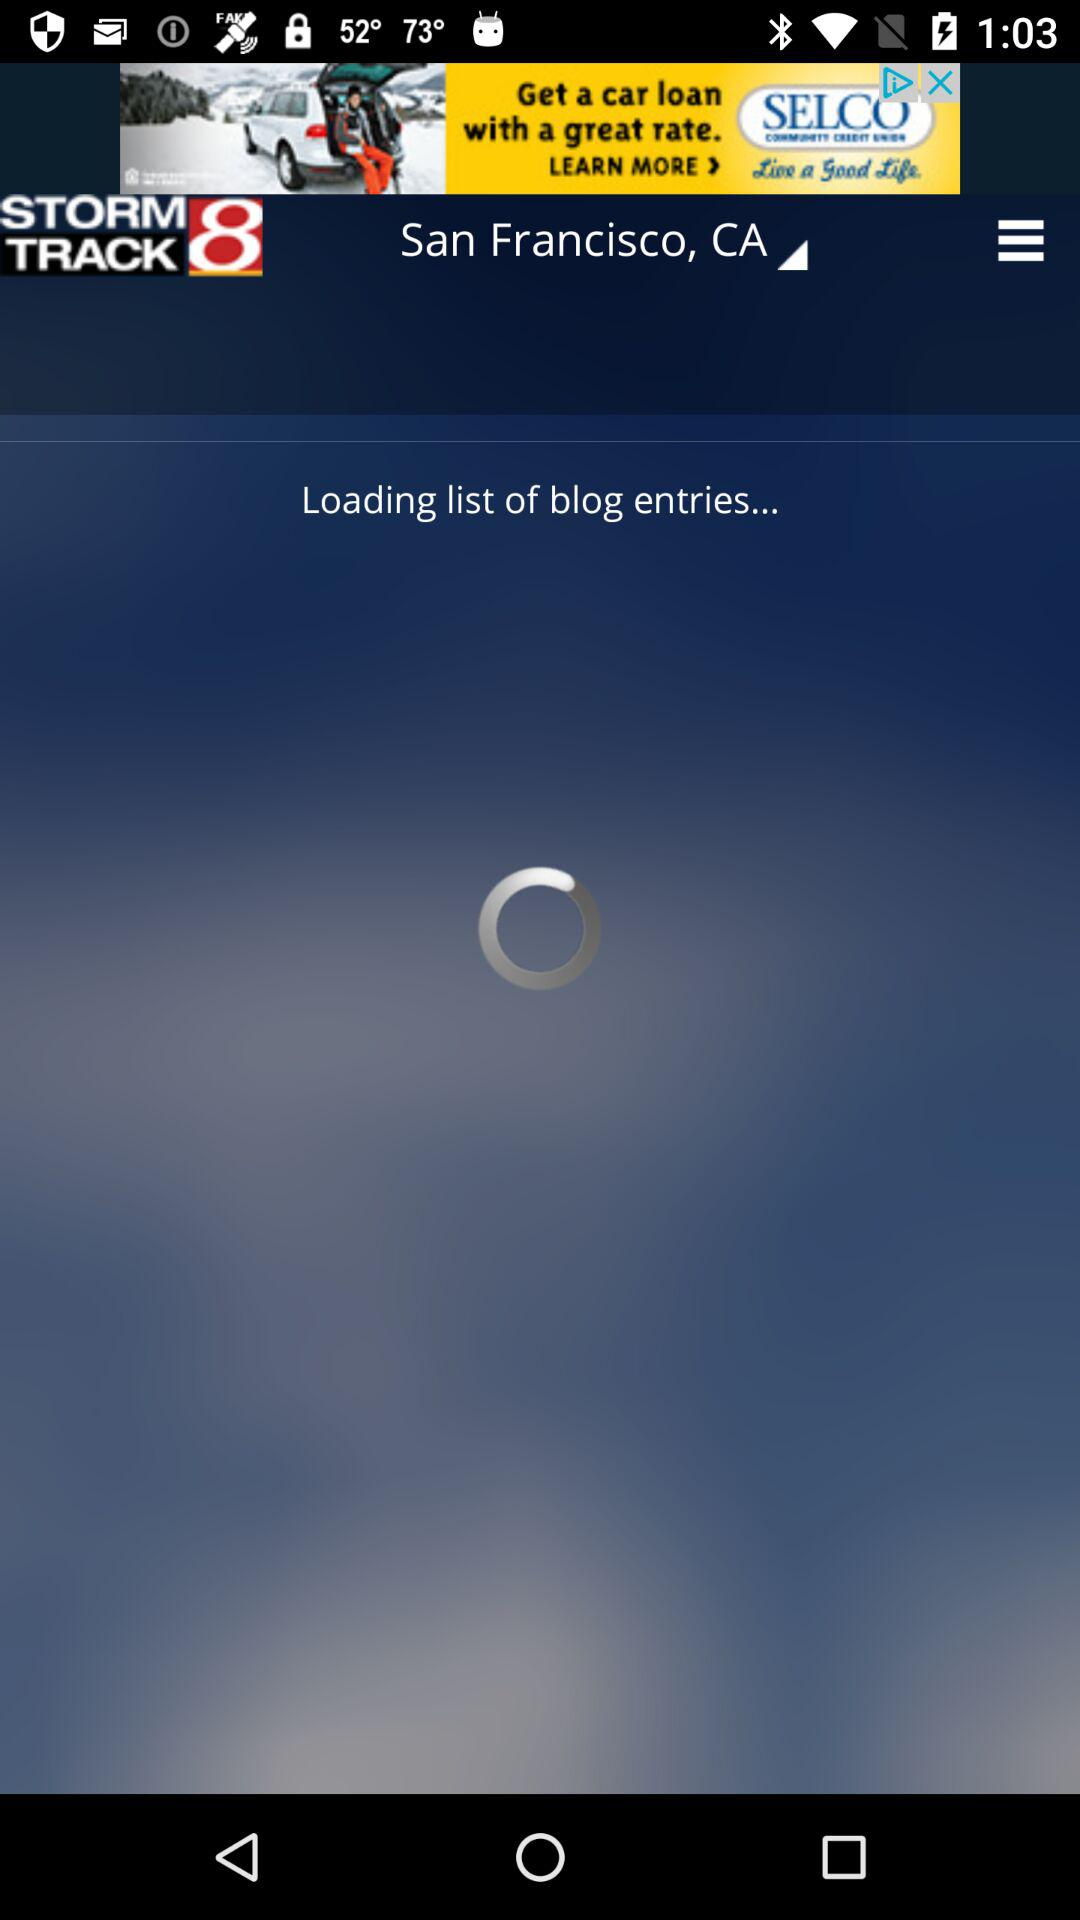What is the list of blog entries?
When the provided information is insufficient, respond with <no answer>. <no answer> 